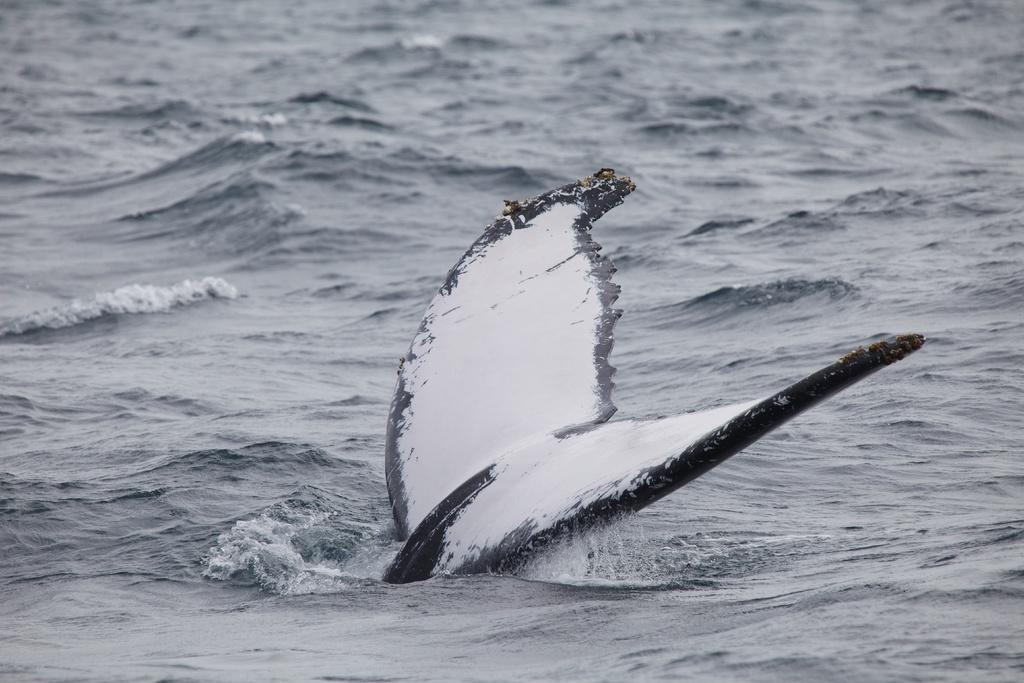What can be seen in the image? There is an object in the image. What is visible in the background of the image? There is water visible in the background of the image. How many planes are flying over the water in the image? There are no planes visible in the image; only an object and water are present. What type of seed can be seen growing near the water in the image? There is no seed present in the image; only an object and water are visible. 